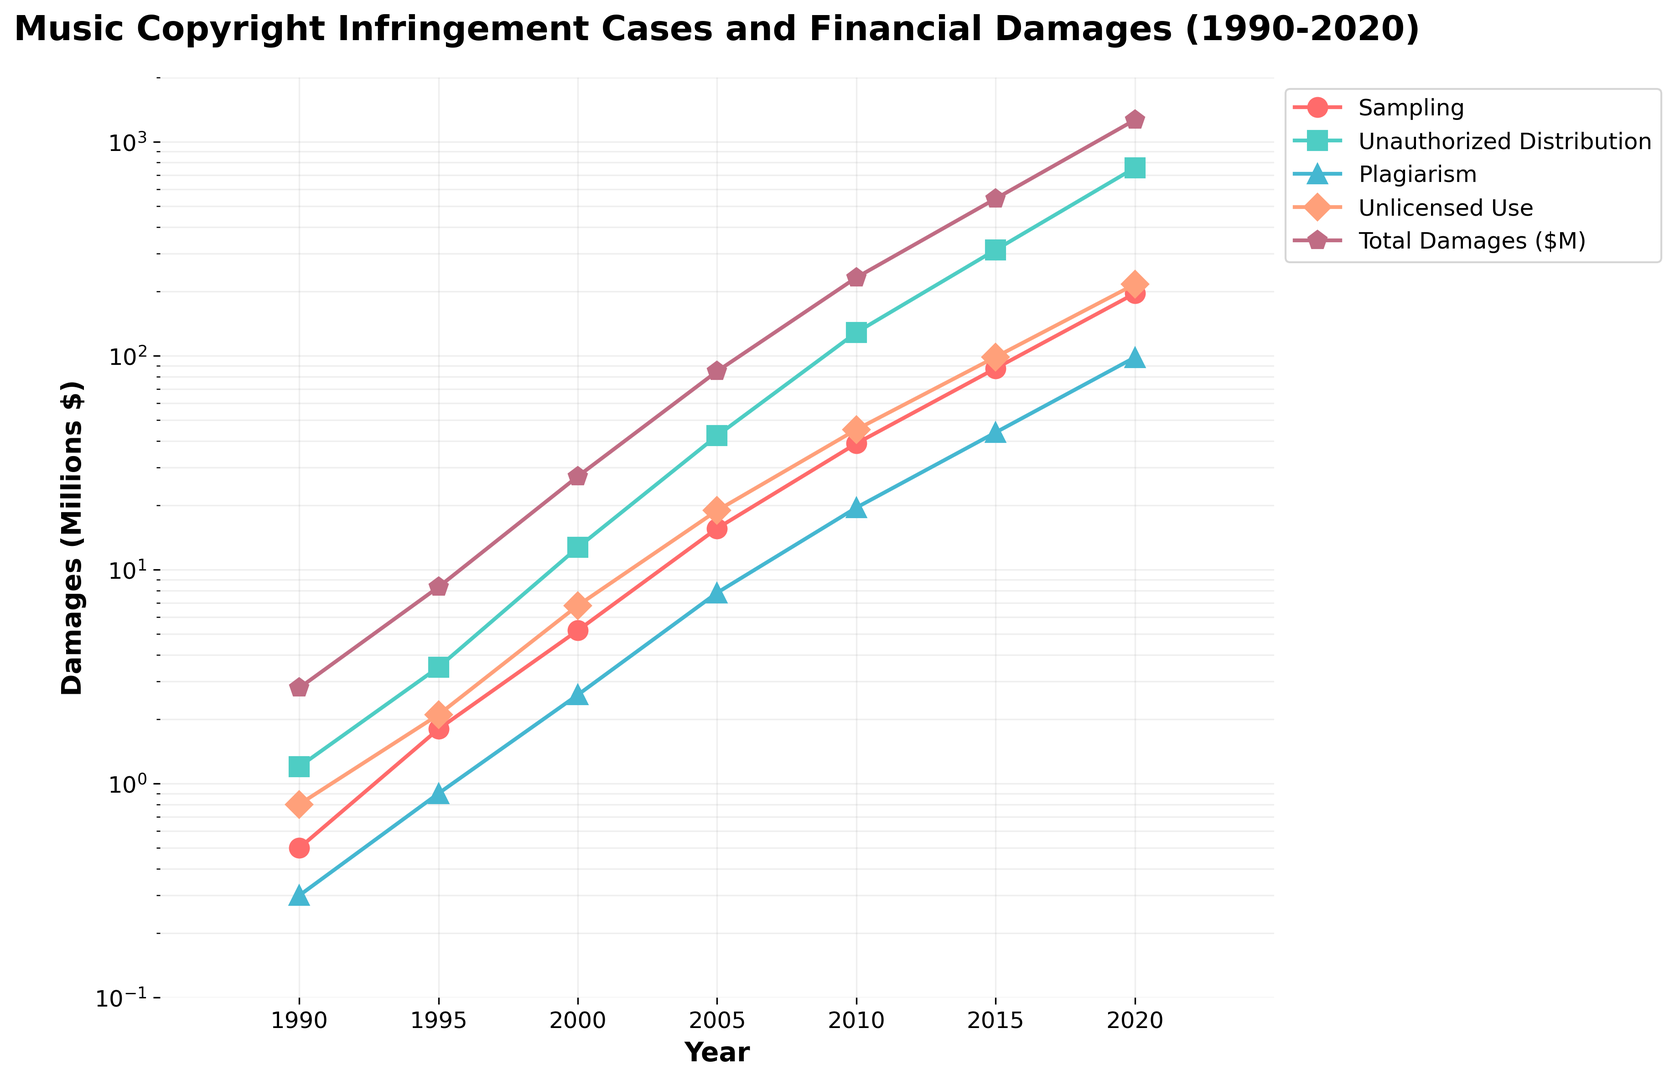What trend do you observe in the 'Total Damages ($M)' category over time? As we look at the 'Total Damages ($M)' line, which is in purple with a pentagon marker, we see a steep upward trend from 1990 to 2020. This indicates a rapid increase in financial damages related to music copyright infringement cases over the years. By 2020, the total damages reach around 1266 million dollars, a significant rise from 2.8 million in 1990.
Answer: It shows a steep upward trend Which type of infringement has the highest associated financial damages in 2020? In 2020, the bar for 'Unauthorized Distribution' (marked in green) reaches the highest point among all categories, significantly surpassing other types of infringement. This indicates that unauthorized distribution was responsible for the highest financial damages in 2020.
Answer: Unauthorized Distribution How does the financial damage from 'Unlicensed Use' in 2010 compare to the damage in 2000? In 2000, the financial damage from 'Unlicensed Use' (marked in salmon) is approximately 6.8 million dollars. By 2010, it rises to around 45.2 million dollars. To compare, subtract the damage in 2000 from the damage in 2010: 45.2 - 6.8 = 38.4 million. This shows a significant increase.
Answer: Increased by 38.4 million dollars What is the ratio of financial damages from 'Sampling' to 'Plagiarism' in 2005? In 2005, the financial damage from 'Sampling' (marked in red) is about 15.6 million dollars, and for 'Plagiarism' (marked in blue), it is around 7.8 million dollars. The ratio is calculated as 15.6 / 7.8 = 2. This indicates that damages from 'Sampling' were twice as much as from 'Plagiarism'.
Answer: 2 Did any type of infringement experience a decrease in financial damages at any point between 1990 and 2020? By visually inspecting the lines for each infringement type from 1990 to 2020, we can see that all categories (Sampling, Unauthorized Distribution, Plagiarism, Unlicensed Use) have consistently increased without showing any decline over any period.
Answer: No What is the overall trend in financial damages from 'Plagiarism' between 1990 and 2020? The financial damages from 'Plagiarism' (marked in blue) show a consistent upward trend from 1990 to 2020. Specifically, it goes from about 0.3 million dollars in 1990 to around 98.3 million dollars by 2020. This indicates a continuous increase with no drops at any point.
Answer: Consistent upward trend How much higher are the total financial damages compared to 'Unlicensed Use' in 2020? In 2020, 'Total Damages ($M)' are around 1266 million dollars, while 'Unlicensed Use' is approximately 215.9 million dollars. The difference can be calculated as 1266 - 215.9 = 1050.1 million dollars. This indicates that the total financial damages are significantly higher than those from 'Unlicensed Use'.
Answer: 1050.1 million dollars What percentage of total damages in 2015 were due to 'Unauthorized Distribution'? In 2015, total damages are about 542.4 million dollars, and damages from 'Unauthorized Distribution' are approximately 312.6 million dollars. The percentage is calculated by (312.6 / 542.4) * 100 = 57.6%. This shows a significant portion of the total damages were due to 'Unauthorized Distribution'.
Answer: 57.6% Has 'Sampling' always been the lowest contributor to financial damages among the types listed from 1990 to 2020? By inspecting the lines, 'Sampling' (in red) generally appears as the lowest contributor each year when compared to 'Unauthorized Distribution', 'Plagiarism', and 'Unlicensed Use', indicating it has mostly been the least impactful in terms of financial damages.
Answer: Yes 